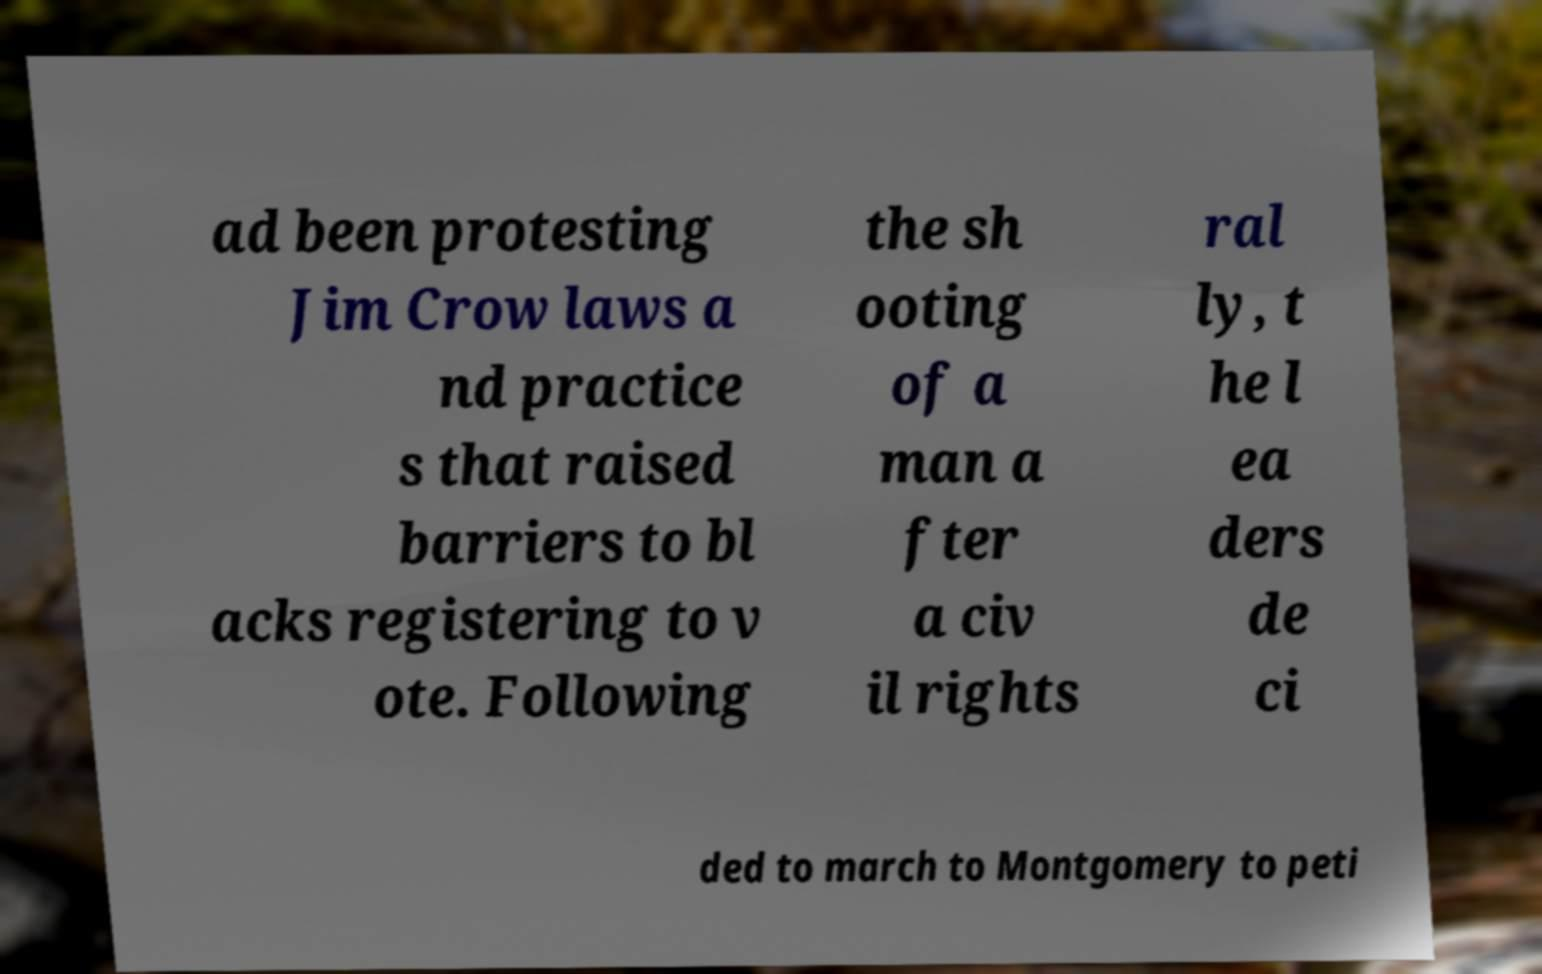Can you read and provide the text displayed in the image?This photo seems to have some interesting text. Can you extract and type it out for me? ad been protesting Jim Crow laws a nd practice s that raised barriers to bl acks registering to v ote. Following the sh ooting of a man a fter a civ il rights ral ly, t he l ea ders de ci ded to march to Montgomery to peti 